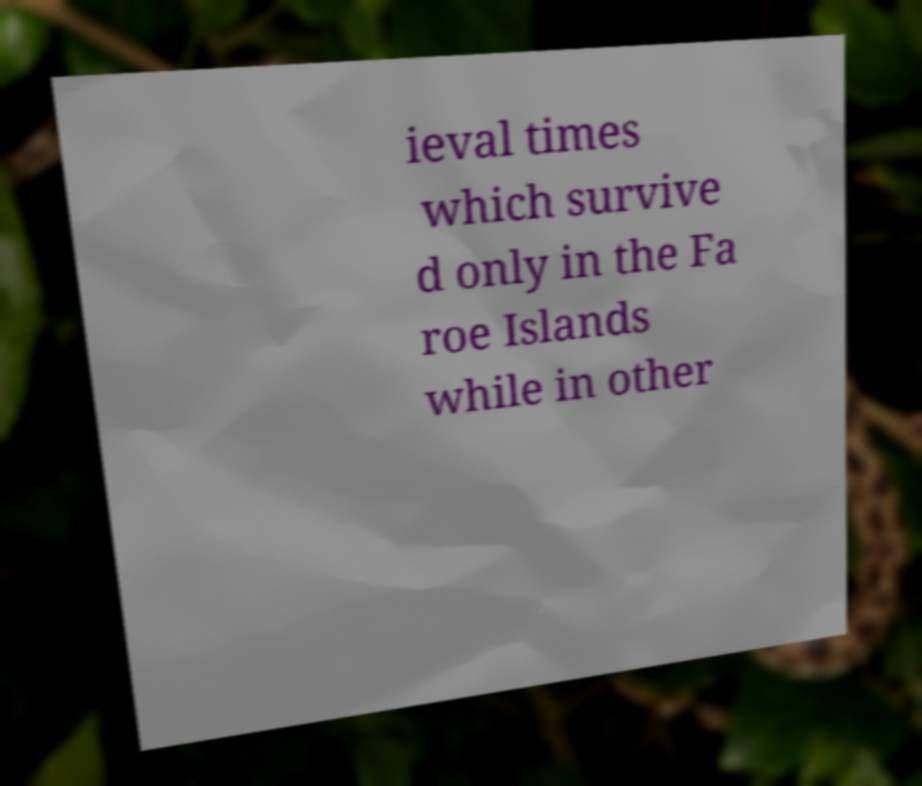Please identify and transcribe the text found in this image. ieval times which survive d only in the Fa roe Islands while in other 